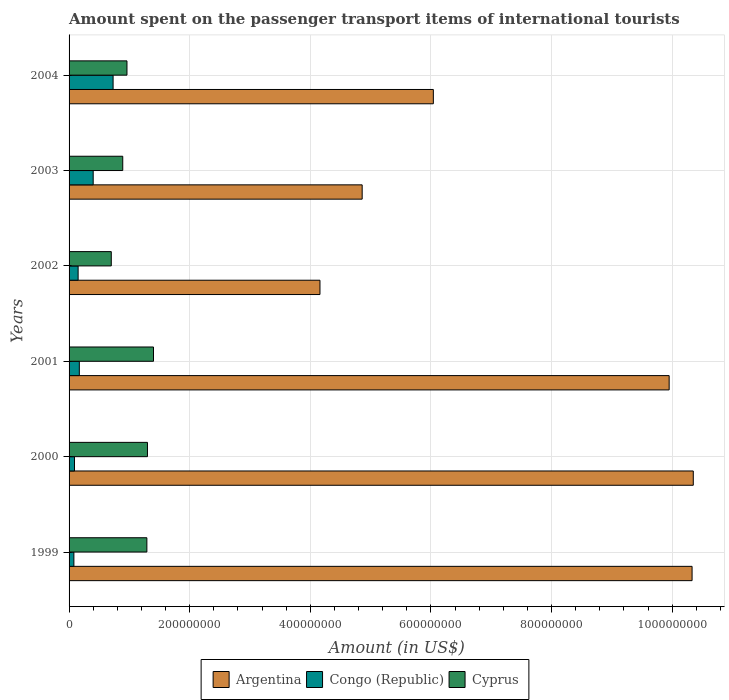How many different coloured bars are there?
Offer a very short reply. 3. Are the number of bars on each tick of the Y-axis equal?
Offer a terse response. Yes. What is the amount spent on the passenger transport items of international tourists in Congo (Republic) in 2002?
Your answer should be very brief. 1.50e+07. Across all years, what is the maximum amount spent on the passenger transport items of international tourists in Congo (Republic)?
Your answer should be very brief. 7.30e+07. Across all years, what is the minimum amount spent on the passenger transport items of international tourists in Argentina?
Provide a short and direct response. 4.16e+08. What is the total amount spent on the passenger transport items of international tourists in Cyprus in the graph?
Offer a very short reply. 6.54e+08. What is the difference between the amount spent on the passenger transport items of international tourists in Cyprus in 1999 and that in 2001?
Offer a terse response. -1.10e+07. What is the difference between the amount spent on the passenger transport items of international tourists in Congo (Republic) in 2000 and the amount spent on the passenger transport items of international tourists in Cyprus in 2001?
Give a very brief answer. -1.31e+08. What is the average amount spent on the passenger transport items of international tourists in Cyprus per year?
Provide a succinct answer. 1.09e+08. In the year 2001, what is the difference between the amount spent on the passenger transport items of international tourists in Cyprus and amount spent on the passenger transport items of international tourists in Argentina?
Keep it short and to the point. -8.55e+08. In how many years, is the amount spent on the passenger transport items of international tourists in Cyprus greater than 480000000 US$?
Make the answer very short. 0. What is the ratio of the amount spent on the passenger transport items of international tourists in Cyprus in 1999 to that in 2002?
Give a very brief answer. 1.84. Is the amount spent on the passenger transport items of international tourists in Argentina in 1999 less than that in 2000?
Your answer should be very brief. Yes. What is the difference between the highest and the second highest amount spent on the passenger transport items of international tourists in Argentina?
Provide a short and direct response. 2.00e+06. What is the difference between the highest and the lowest amount spent on the passenger transport items of international tourists in Congo (Republic)?
Your answer should be very brief. 6.50e+07. In how many years, is the amount spent on the passenger transport items of international tourists in Cyprus greater than the average amount spent on the passenger transport items of international tourists in Cyprus taken over all years?
Give a very brief answer. 3. What does the 3rd bar from the bottom in 2004 represents?
Make the answer very short. Cyprus. Is it the case that in every year, the sum of the amount spent on the passenger transport items of international tourists in Cyprus and amount spent on the passenger transport items of international tourists in Argentina is greater than the amount spent on the passenger transport items of international tourists in Congo (Republic)?
Make the answer very short. Yes. Does the graph contain any zero values?
Offer a terse response. No. Does the graph contain grids?
Provide a succinct answer. Yes. How many legend labels are there?
Your response must be concise. 3. How are the legend labels stacked?
Keep it short and to the point. Horizontal. What is the title of the graph?
Give a very brief answer. Amount spent on the passenger transport items of international tourists. What is the label or title of the X-axis?
Provide a short and direct response. Amount (in US$). What is the label or title of the Y-axis?
Ensure brevity in your answer.  Years. What is the Amount (in US$) of Argentina in 1999?
Ensure brevity in your answer.  1.03e+09. What is the Amount (in US$) in Congo (Republic) in 1999?
Your answer should be compact. 8.00e+06. What is the Amount (in US$) of Cyprus in 1999?
Your answer should be compact. 1.29e+08. What is the Amount (in US$) in Argentina in 2000?
Offer a terse response. 1.04e+09. What is the Amount (in US$) in Congo (Republic) in 2000?
Keep it short and to the point. 9.00e+06. What is the Amount (in US$) in Cyprus in 2000?
Ensure brevity in your answer.  1.30e+08. What is the Amount (in US$) in Argentina in 2001?
Offer a terse response. 9.95e+08. What is the Amount (in US$) in Congo (Republic) in 2001?
Give a very brief answer. 1.70e+07. What is the Amount (in US$) of Cyprus in 2001?
Your answer should be compact. 1.40e+08. What is the Amount (in US$) in Argentina in 2002?
Ensure brevity in your answer.  4.16e+08. What is the Amount (in US$) of Congo (Republic) in 2002?
Your response must be concise. 1.50e+07. What is the Amount (in US$) of Cyprus in 2002?
Your answer should be compact. 7.00e+07. What is the Amount (in US$) in Argentina in 2003?
Your answer should be compact. 4.86e+08. What is the Amount (in US$) of Congo (Republic) in 2003?
Ensure brevity in your answer.  4.00e+07. What is the Amount (in US$) of Cyprus in 2003?
Give a very brief answer. 8.90e+07. What is the Amount (in US$) of Argentina in 2004?
Keep it short and to the point. 6.04e+08. What is the Amount (in US$) of Congo (Republic) in 2004?
Offer a terse response. 7.30e+07. What is the Amount (in US$) in Cyprus in 2004?
Your answer should be compact. 9.60e+07. Across all years, what is the maximum Amount (in US$) of Argentina?
Keep it short and to the point. 1.04e+09. Across all years, what is the maximum Amount (in US$) in Congo (Republic)?
Give a very brief answer. 7.30e+07. Across all years, what is the maximum Amount (in US$) in Cyprus?
Offer a terse response. 1.40e+08. Across all years, what is the minimum Amount (in US$) in Argentina?
Your response must be concise. 4.16e+08. Across all years, what is the minimum Amount (in US$) in Cyprus?
Offer a very short reply. 7.00e+07. What is the total Amount (in US$) in Argentina in the graph?
Ensure brevity in your answer.  4.57e+09. What is the total Amount (in US$) in Congo (Republic) in the graph?
Offer a very short reply. 1.62e+08. What is the total Amount (in US$) of Cyprus in the graph?
Provide a short and direct response. 6.54e+08. What is the difference between the Amount (in US$) in Cyprus in 1999 and that in 2000?
Your answer should be very brief. -1.00e+06. What is the difference between the Amount (in US$) in Argentina in 1999 and that in 2001?
Ensure brevity in your answer.  3.80e+07. What is the difference between the Amount (in US$) in Congo (Republic) in 1999 and that in 2001?
Your answer should be very brief. -9.00e+06. What is the difference between the Amount (in US$) in Cyprus in 1999 and that in 2001?
Make the answer very short. -1.10e+07. What is the difference between the Amount (in US$) of Argentina in 1999 and that in 2002?
Your response must be concise. 6.17e+08. What is the difference between the Amount (in US$) of Congo (Republic) in 1999 and that in 2002?
Provide a short and direct response. -7.00e+06. What is the difference between the Amount (in US$) of Cyprus in 1999 and that in 2002?
Keep it short and to the point. 5.90e+07. What is the difference between the Amount (in US$) of Argentina in 1999 and that in 2003?
Keep it short and to the point. 5.47e+08. What is the difference between the Amount (in US$) in Congo (Republic) in 1999 and that in 2003?
Your answer should be compact. -3.20e+07. What is the difference between the Amount (in US$) of Cyprus in 1999 and that in 2003?
Your answer should be compact. 4.00e+07. What is the difference between the Amount (in US$) in Argentina in 1999 and that in 2004?
Your answer should be compact. 4.29e+08. What is the difference between the Amount (in US$) of Congo (Republic) in 1999 and that in 2004?
Offer a very short reply. -6.50e+07. What is the difference between the Amount (in US$) of Cyprus in 1999 and that in 2004?
Make the answer very short. 3.30e+07. What is the difference between the Amount (in US$) in Argentina in 2000 and that in 2001?
Make the answer very short. 4.00e+07. What is the difference between the Amount (in US$) in Congo (Republic) in 2000 and that in 2001?
Offer a very short reply. -8.00e+06. What is the difference between the Amount (in US$) of Cyprus in 2000 and that in 2001?
Give a very brief answer. -1.00e+07. What is the difference between the Amount (in US$) of Argentina in 2000 and that in 2002?
Provide a short and direct response. 6.19e+08. What is the difference between the Amount (in US$) in Congo (Republic) in 2000 and that in 2002?
Provide a succinct answer. -6.00e+06. What is the difference between the Amount (in US$) in Cyprus in 2000 and that in 2002?
Keep it short and to the point. 6.00e+07. What is the difference between the Amount (in US$) of Argentina in 2000 and that in 2003?
Your answer should be compact. 5.49e+08. What is the difference between the Amount (in US$) of Congo (Republic) in 2000 and that in 2003?
Your answer should be very brief. -3.10e+07. What is the difference between the Amount (in US$) of Cyprus in 2000 and that in 2003?
Make the answer very short. 4.10e+07. What is the difference between the Amount (in US$) in Argentina in 2000 and that in 2004?
Your answer should be very brief. 4.31e+08. What is the difference between the Amount (in US$) in Congo (Republic) in 2000 and that in 2004?
Your answer should be very brief. -6.40e+07. What is the difference between the Amount (in US$) of Cyprus in 2000 and that in 2004?
Make the answer very short. 3.40e+07. What is the difference between the Amount (in US$) in Argentina in 2001 and that in 2002?
Your answer should be very brief. 5.79e+08. What is the difference between the Amount (in US$) of Congo (Republic) in 2001 and that in 2002?
Provide a succinct answer. 2.00e+06. What is the difference between the Amount (in US$) of Cyprus in 2001 and that in 2002?
Make the answer very short. 7.00e+07. What is the difference between the Amount (in US$) of Argentina in 2001 and that in 2003?
Make the answer very short. 5.09e+08. What is the difference between the Amount (in US$) in Congo (Republic) in 2001 and that in 2003?
Give a very brief answer. -2.30e+07. What is the difference between the Amount (in US$) in Cyprus in 2001 and that in 2003?
Your answer should be very brief. 5.10e+07. What is the difference between the Amount (in US$) in Argentina in 2001 and that in 2004?
Your answer should be very brief. 3.91e+08. What is the difference between the Amount (in US$) in Congo (Republic) in 2001 and that in 2004?
Make the answer very short. -5.60e+07. What is the difference between the Amount (in US$) of Cyprus in 2001 and that in 2004?
Your answer should be compact. 4.40e+07. What is the difference between the Amount (in US$) of Argentina in 2002 and that in 2003?
Offer a very short reply. -7.00e+07. What is the difference between the Amount (in US$) in Congo (Republic) in 2002 and that in 2003?
Provide a succinct answer. -2.50e+07. What is the difference between the Amount (in US$) in Cyprus in 2002 and that in 2003?
Provide a succinct answer. -1.90e+07. What is the difference between the Amount (in US$) of Argentina in 2002 and that in 2004?
Ensure brevity in your answer.  -1.88e+08. What is the difference between the Amount (in US$) in Congo (Republic) in 2002 and that in 2004?
Provide a succinct answer. -5.80e+07. What is the difference between the Amount (in US$) in Cyprus in 2002 and that in 2004?
Offer a very short reply. -2.60e+07. What is the difference between the Amount (in US$) of Argentina in 2003 and that in 2004?
Your answer should be compact. -1.18e+08. What is the difference between the Amount (in US$) of Congo (Republic) in 2003 and that in 2004?
Keep it short and to the point. -3.30e+07. What is the difference between the Amount (in US$) of Cyprus in 2003 and that in 2004?
Your answer should be compact. -7.00e+06. What is the difference between the Amount (in US$) of Argentina in 1999 and the Amount (in US$) of Congo (Republic) in 2000?
Give a very brief answer. 1.02e+09. What is the difference between the Amount (in US$) of Argentina in 1999 and the Amount (in US$) of Cyprus in 2000?
Give a very brief answer. 9.03e+08. What is the difference between the Amount (in US$) in Congo (Republic) in 1999 and the Amount (in US$) in Cyprus in 2000?
Your response must be concise. -1.22e+08. What is the difference between the Amount (in US$) in Argentina in 1999 and the Amount (in US$) in Congo (Republic) in 2001?
Your answer should be compact. 1.02e+09. What is the difference between the Amount (in US$) in Argentina in 1999 and the Amount (in US$) in Cyprus in 2001?
Your response must be concise. 8.93e+08. What is the difference between the Amount (in US$) in Congo (Republic) in 1999 and the Amount (in US$) in Cyprus in 2001?
Your answer should be very brief. -1.32e+08. What is the difference between the Amount (in US$) in Argentina in 1999 and the Amount (in US$) in Congo (Republic) in 2002?
Keep it short and to the point. 1.02e+09. What is the difference between the Amount (in US$) of Argentina in 1999 and the Amount (in US$) of Cyprus in 2002?
Give a very brief answer. 9.63e+08. What is the difference between the Amount (in US$) in Congo (Republic) in 1999 and the Amount (in US$) in Cyprus in 2002?
Your answer should be compact. -6.20e+07. What is the difference between the Amount (in US$) of Argentina in 1999 and the Amount (in US$) of Congo (Republic) in 2003?
Give a very brief answer. 9.93e+08. What is the difference between the Amount (in US$) of Argentina in 1999 and the Amount (in US$) of Cyprus in 2003?
Make the answer very short. 9.44e+08. What is the difference between the Amount (in US$) of Congo (Republic) in 1999 and the Amount (in US$) of Cyprus in 2003?
Provide a short and direct response. -8.10e+07. What is the difference between the Amount (in US$) in Argentina in 1999 and the Amount (in US$) in Congo (Republic) in 2004?
Your response must be concise. 9.60e+08. What is the difference between the Amount (in US$) in Argentina in 1999 and the Amount (in US$) in Cyprus in 2004?
Provide a succinct answer. 9.37e+08. What is the difference between the Amount (in US$) in Congo (Republic) in 1999 and the Amount (in US$) in Cyprus in 2004?
Ensure brevity in your answer.  -8.80e+07. What is the difference between the Amount (in US$) of Argentina in 2000 and the Amount (in US$) of Congo (Republic) in 2001?
Your answer should be compact. 1.02e+09. What is the difference between the Amount (in US$) in Argentina in 2000 and the Amount (in US$) in Cyprus in 2001?
Provide a short and direct response. 8.95e+08. What is the difference between the Amount (in US$) in Congo (Republic) in 2000 and the Amount (in US$) in Cyprus in 2001?
Keep it short and to the point. -1.31e+08. What is the difference between the Amount (in US$) in Argentina in 2000 and the Amount (in US$) in Congo (Republic) in 2002?
Offer a terse response. 1.02e+09. What is the difference between the Amount (in US$) in Argentina in 2000 and the Amount (in US$) in Cyprus in 2002?
Provide a short and direct response. 9.65e+08. What is the difference between the Amount (in US$) of Congo (Republic) in 2000 and the Amount (in US$) of Cyprus in 2002?
Offer a terse response. -6.10e+07. What is the difference between the Amount (in US$) in Argentina in 2000 and the Amount (in US$) in Congo (Republic) in 2003?
Your answer should be very brief. 9.95e+08. What is the difference between the Amount (in US$) of Argentina in 2000 and the Amount (in US$) of Cyprus in 2003?
Give a very brief answer. 9.46e+08. What is the difference between the Amount (in US$) in Congo (Republic) in 2000 and the Amount (in US$) in Cyprus in 2003?
Provide a succinct answer. -8.00e+07. What is the difference between the Amount (in US$) in Argentina in 2000 and the Amount (in US$) in Congo (Republic) in 2004?
Your answer should be compact. 9.62e+08. What is the difference between the Amount (in US$) in Argentina in 2000 and the Amount (in US$) in Cyprus in 2004?
Give a very brief answer. 9.39e+08. What is the difference between the Amount (in US$) in Congo (Republic) in 2000 and the Amount (in US$) in Cyprus in 2004?
Keep it short and to the point. -8.70e+07. What is the difference between the Amount (in US$) of Argentina in 2001 and the Amount (in US$) of Congo (Republic) in 2002?
Provide a succinct answer. 9.80e+08. What is the difference between the Amount (in US$) in Argentina in 2001 and the Amount (in US$) in Cyprus in 2002?
Your response must be concise. 9.25e+08. What is the difference between the Amount (in US$) of Congo (Republic) in 2001 and the Amount (in US$) of Cyprus in 2002?
Your answer should be compact. -5.30e+07. What is the difference between the Amount (in US$) in Argentina in 2001 and the Amount (in US$) in Congo (Republic) in 2003?
Ensure brevity in your answer.  9.55e+08. What is the difference between the Amount (in US$) in Argentina in 2001 and the Amount (in US$) in Cyprus in 2003?
Make the answer very short. 9.06e+08. What is the difference between the Amount (in US$) in Congo (Republic) in 2001 and the Amount (in US$) in Cyprus in 2003?
Give a very brief answer. -7.20e+07. What is the difference between the Amount (in US$) in Argentina in 2001 and the Amount (in US$) in Congo (Republic) in 2004?
Your response must be concise. 9.22e+08. What is the difference between the Amount (in US$) of Argentina in 2001 and the Amount (in US$) of Cyprus in 2004?
Provide a short and direct response. 8.99e+08. What is the difference between the Amount (in US$) in Congo (Republic) in 2001 and the Amount (in US$) in Cyprus in 2004?
Your answer should be compact. -7.90e+07. What is the difference between the Amount (in US$) of Argentina in 2002 and the Amount (in US$) of Congo (Republic) in 2003?
Keep it short and to the point. 3.76e+08. What is the difference between the Amount (in US$) in Argentina in 2002 and the Amount (in US$) in Cyprus in 2003?
Offer a very short reply. 3.27e+08. What is the difference between the Amount (in US$) in Congo (Republic) in 2002 and the Amount (in US$) in Cyprus in 2003?
Provide a succinct answer. -7.40e+07. What is the difference between the Amount (in US$) of Argentina in 2002 and the Amount (in US$) of Congo (Republic) in 2004?
Ensure brevity in your answer.  3.43e+08. What is the difference between the Amount (in US$) of Argentina in 2002 and the Amount (in US$) of Cyprus in 2004?
Your answer should be compact. 3.20e+08. What is the difference between the Amount (in US$) in Congo (Republic) in 2002 and the Amount (in US$) in Cyprus in 2004?
Keep it short and to the point. -8.10e+07. What is the difference between the Amount (in US$) in Argentina in 2003 and the Amount (in US$) in Congo (Republic) in 2004?
Give a very brief answer. 4.13e+08. What is the difference between the Amount (in US$) of Argentina in 2003 and the Amount (in US$) of Cyprus in 2004?
Provide a short and direct response. 3.90e+08. What is the difference between the Amount (in US$) in Congo (Republic) in 2003 and the Amount (in US$) in Cyprus in 2004?
Ensure brevity in your answer.  -5.60e+07. What is the average Amount (in US$) of Argentina per year?
Your response must be concise. 7.62e+08. What is the average Amount (in US$) of Congo (Republic) per year?
Your response must be concise. 2.70e+07. What is the average Amount (in US$) in Cyprus per year?
Provide a short and direct response. 1.09e+08. In the year 1999, what is the difference between the Amount (in US$) of Argentina and Amount (in US$) of Congo (Republic)?
Provide a short and direct response. 1.02e+09. In the year 1999, what is the difference between the Amount (in US$) in Argentina and Amount (in US$) in Cyprus?
Keep it short and to the point. 9.04e+08. In the year 1999, what is the difference between the Amount (in US$) of Congo (Republic) and Amount (in US$) of Cyprus?
Make the answer very short. -1.21e+08. In the year 2000, what is the difference between the Amount (in US$) of Argentina and Amount (in US$) of Congo (Republic)?
Give a very brief answer. 1.03e+09. In the year 2000, what is the difference between the Amount (in US$) in Argentina and Amount (in US$) in Cyprus?
Keep it short and to the point. 9.05e+08. In the year 2000, what is the difference between the Amount (in US$) of Congo (Republic) and Amount (in US$) of Cyprus?
Ensure brevity in your answer.  -1.21e+08. In the year 2001, what is the difference between the Amount (in US$) of Argentina and Amount (in US$) of Congo (Republic)?
Ensure brevity in your answer.  9.78e+08. In the year 2001, what is the difference between the Amount (in US$) of Argentina and Amount (in US$) of Cyprus?
Keep it short and to the point. 8.55e+08. In the year 2001, what is the difference between the Amount (in US$) in Congo (Republic) and Amount (in US$) in Cyprus?
Provide a short and direct response. -1.23e+08. In the year 2002, what is the difference between the Amount (in US$) in Argentina and Amount (in US$) in Congo (Republic)?
Offer a very short reply. 4.01e+08. In the year 2002, what is the difference between the Amount (in US$) of Argentina and Amount (in US$) of Cyprus?
Your response must be concise. 3.46e+08. In the year 2002, what is the difference between the Amount (in US$) of Congo (Republic) and Amount (in US$) of Cyprus?
Ensure brevity in your answer.  -5.50e+07. In the year 2003, what is the difference between the Amount (in US$) in Argentina and Amount (in US$) in Congo (Republic)?
Ensure brevity in your answer.  4.46e+08. In the year 2003, what is the difference between the Amount (in US$) in Argentina and Amount (in US$) in Cyprus?
Make the answer very short. 3.97e+08. In the year 2003, what is the difference between the Amount (in US$) of Congo (Republic) and Amount (in US$) of Cyprus?
Provide a short and direct response. -4.90e+07. In the year 2004, what is the difference between the Amount (in US$) of Argentina and Amount (in US$) of Congo (Republic)?
Make the answer very short. 5.31e+08. In the year 2004, what is the difference between the Amount (in US$) in Argentina and Amount (in US$) in Cyprus?
Your answer should be compact. 5.08e+08. In the year 2004, what is the difference between the Amount (in US$) of Congo (Republic) and Amount (in US$) of Cyprus?
Your response must be concise. -2.30e+07. What is the ratio of the Amount (in US$) in Cyprus in 1999 to that in 2000?
Provide a succinct answer. 0.99. What is the ratio of the Amount (in US$) of Argentina in 1999 to that in 2001?
Make the answer very short. 1.04. What is the ratio of the Amount (in US$) in Congo (Republic) in 1999 to that in 2001?
Make the answer very short. 0.47. What is the ratio of the Amount (in US$) of Cyprus in 1999 to that in 2001?
Offer a terse response. 0.92. What is the ratio of the Amount (in US$) of Argentina in 1999 to that in 2002?
Give a very brief answer. 2.48. What is the ratio of the Amount (in US$) of Congo (Republic) in 1999 to that in 2002?
Give a very brief answer. 0.53. What is the ratio of the Amount (in US$) of Cyprus in 1999 to that in 2002?
Offer a very short reply. 1.84. What is the ratio of the Amount (in US$) in Argentina in 1999 to that in 2003?
Your response must be concise. 2.13. What is the ratio of the Amount (in US$) of Congo (Republic) in 1999 to that in 2003?
Your answer should be compact. 0.2. What is the ratio of the Amount (in US$) of Cyprus in 1999 to that in 2003?
Provide a short and direct response. 1.45. What is the ratio of the Amount (in US$) in Argentina in 1999 to that in 2004?
Ensure brevity in your answer.  1.71. What is the ratio of the Amount (in US$) in Congo (Republic) in 1999 to that in 2004?
Your response must be concise. 0.11. What is the ratio of the Amount (in US$) of Cyprus in 1999 to that in 2004?
Give a very brief answer. 1.34. What is the ratio of the Amount (in US$) in Argentina in 2000 to that in 2001?
Ensure brevity in your answer.  1.04. What is the ratio of the Amount (in US$) in Congo (Republic) in 2000 to that in 2001?
Give a very brief answer. 0.53. What is the ratio of the Amount (in US$) of Argentina in 2000 to that in 2002?
Offer a terse response. 2.49. What is the ratio of the Amount (in US$) in Cyprus in 2000 to that in 2002?
Give a very brief answer. 1.86. What is the ratio of the Amount (in US$) of Argentina in 2000 to that in 2003?
Give a very brief answer. 2.13. What is the ratio of the Amount (in US$) in Congo (Republic) in 2000 to that in 2003?
Give a very brief answer. 0.23. What is the ratio of the Amount (in US$) of Cyprus in 2000 to that in 2003?
Keep it short and to the point. 1.46. What is the ratio of the Amount (in US$) of Argentina in 2000 to that in 2004?
Offer a terse response. 1.71. What is the ratio of the Amount (in US$) in Congo (Republic) in 2000 to that in 2004?
Offer a terse response. 0.12. What is the ratio of the Amount (in US$) in Cyprus in 2000 to that in 2004?
Provide a short and direct response. 1.35. What is the ratio of the Amount (in US$) of Argentina in 2001 to that in 2002?
Offer a very short reply. 2.39. What is the ratio of the Amount (in US$) of Congo (Republic) in 2001 to that in 2002?
Ensure brevity in your answer.  1.13. What is the ratio of the Amount (in US$) of Argentina in 2001 to that in 2003?
Provide a succinct answer. 2.05. What is the ratio of the Amount (in US$) in Congo (Republic) in 2001 to that in 2003?
Provide a succinct answer. 0.42. What is the ratio of the Amount (in US$) of Cyprus in 2001 to that in 2003?
Give a very brief answer. 1.57. What is the ratio of the Amount (in US$) of Argentina in 2001 to that in 2004?
Your response must be concise. 1.65. What is the ratio of the Amount (in US$) of Congo (Republic) in 2001 to that in 2004?
Your response must be concise. 0.23. What is the ratio of the Amount (in US$) of Cyprus in 2001 to that in 2004?
Your answer should be compact. 1.46. What is the ratio of the Amount (in US$) of Argentina in 2002 to that in 2003?
Offer a very short reply. 0.86. What is the ratio of the Amount (in US$) in Congo (Republic) in 2002 to that in 2003?
Keep it short and to the point. 0.38. What is the ratio of the Amount (in US$) of Cyprus in 2002 to that in 2003?
Make the answer very short. 0.79. What is the ratio of the Amount (in US$) of Argentina in 2002 to that in 2004?
Provide a short and direct response. 0.69. What is the ratio of the Amount (in US$) in Congo (Republic) in 2002 to that in 2004?
Your response must be concise. 0.21. What is the ratio of the Amount (in US$) of Cyprus in 2002 to that in 2004?
Your response must be concise. 0.73. What is the ratio of the Amount (in US$) of Argentina in 2003 to that in 2004?
Make the answer very short. 0.8. What is the ratio of the Amount (in US$) of Congo (Republic) in 2003 to that in 2004?
Your response must be concise. 0.55. What is the ratio of the Amount (in US$) in Cyprus in 2003 to that in 2004?
Offer a very short reply. 0.93. What is the difference between the highest and the second highest Amount (in US$) of Argentina?
Your response must be concise. 2.00e+06. What is the difference between the highest and the second highest Amount (in US$) of Congo (Republic)?
Offer a very short reply. 3.30e+07. What is the difference between the highest and the second highest Amount (in US$) of Cyprus?
Make the answer very short. 1.00e+07. What is the difference between the highest and the lowest Amount (in US$) in Argentina?
Offer a terse response. 6.19e+08. What is the difference between the highest and the lowest Amount (in US$) in Congo (Republic)?
Ensure brevity in your answer.  6.50e+07. What is the difference between the highest and the lowest Amount (in US$) in Cyprus?
Give a very brief answer. 7.00e+07. 